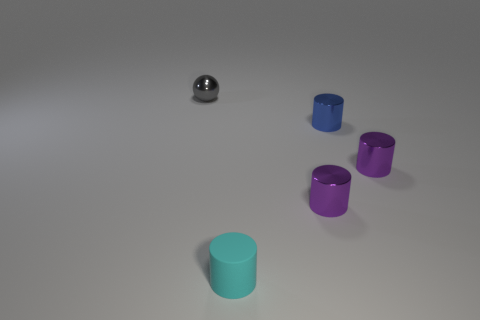Add 3 purple objects. How many objects exist? 8 Subtract all spheres. How many objects are left? 4 Subtract 0 blue balls. How many objects are left? 5 Subtract all large blue matte things. Subtract all tiny matte cylinders. How many objects are left? 4 Add 2 tiny cyan matte cylinders. How many tiny cyan matte cylinders are left? 3 Add 5 matte cylinders. How many matte cylinders exist? 6 